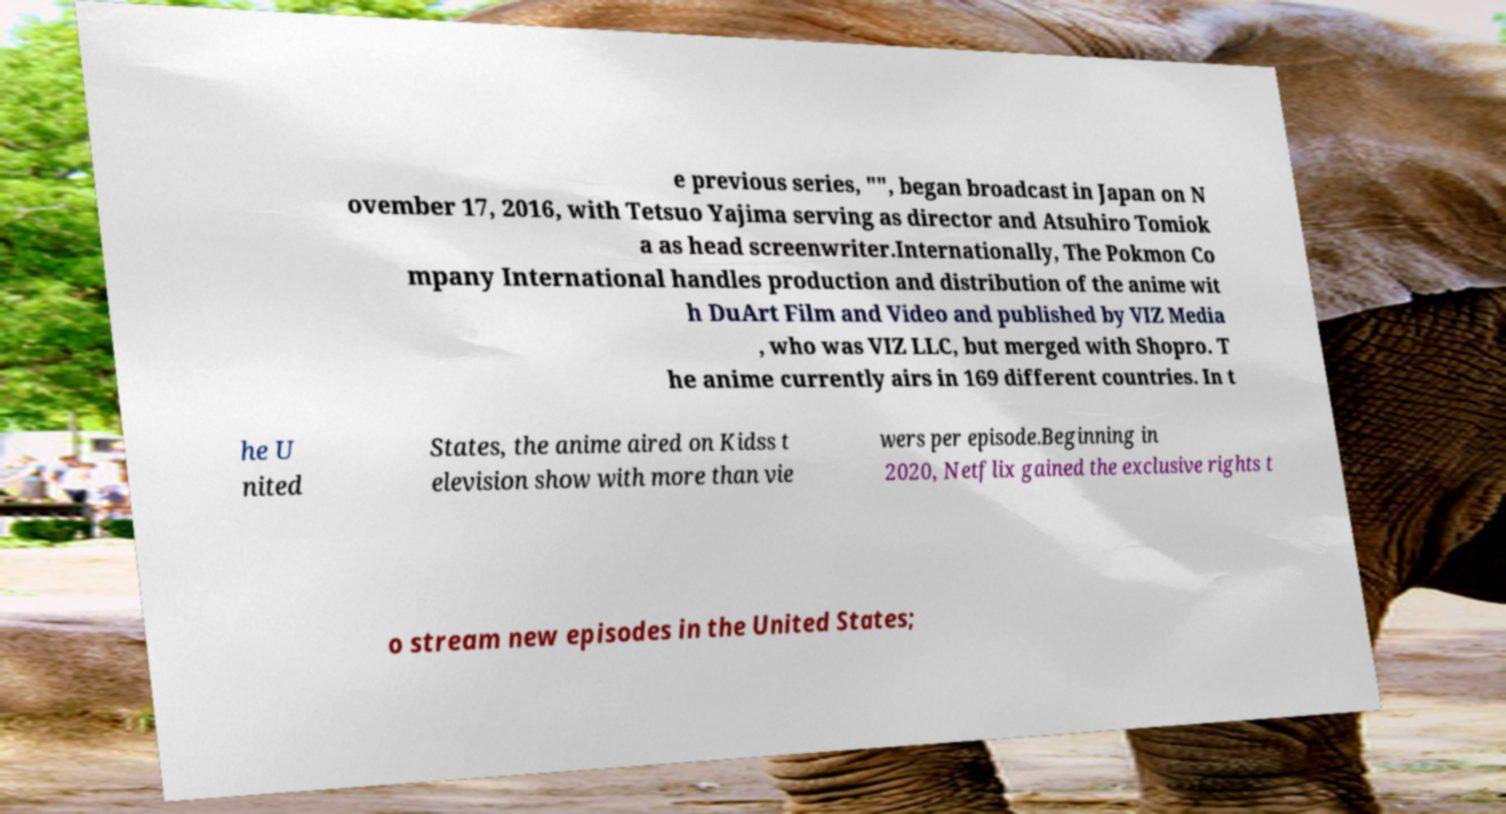For documentation purposes, I need the text within this image transcribed. Could you provide that? e previous series, "", began broadcast in Japan on N ovember 17, 2016, with Tetsuo Yajima serving as director and Atsuhiro Tomiok a as head screenwriter.Internationally, The Pokmon Co mpany International handles production and distribution of the anime wit h DuArt Film and Video and published by VIZ Media , who was VIZ LLC, but merged with Shopro. T he anime currently airs in 169 different countries. In t he U nited States, the anime aired on Kidss t elevision show with more than vie wers per episode.Beginning in 2020, Netflix gained the exclusive rights t o stream new episodes in the United States; 